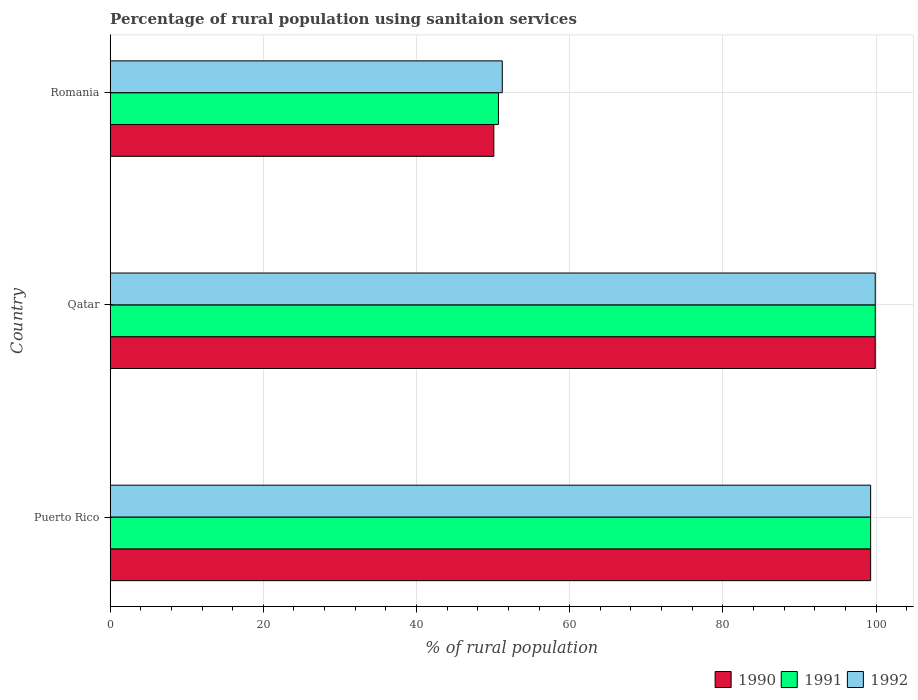How many groups of bars are there?
Your answer should be very brief. 3. Are the number of bars per tick equal to the number of legend labels?
Provide a succinct answer. Yes. What is the label of the 2nd group of bars from the top?
Ensure brevity in your answer.  Qatar. What is the percentage of rural population using sanitaion services in 1990 in Romania?
Your response must be concise. 50.1. Across all countries, what is the maximum percentage of rural population using sanitaion services in 1991?
Your response must be concise. 99.9. Across all countries, what is the minimum percentage of rural population using sanitaion services in 1990?
Your response must be concise. 50.1. In which country was the percentage of rural population using sanitaion services in 1991 maximum?
Offer a very short reply. Qatar. In which country was the percentage of rural population using sanitaion services in 1991 minimum?
Your answer should be very brief. Romania. What is the total percentage of rural population using sanitaion services in 1991 in the graph?
Your answer should be very brief. 249.9. What is the difference between the percentage of rural population using sanitaion services in 1990 in Puerto Rico and that in Romania?
Keep it short and to the point. 49.2. What is the difference between the percentage of rural population using sanitaion services in 1991 in Qatar and the percentage of rural population using sanitaion services in 1990 in Puerto Rico?
Offer a very short reply. 0.6. What is the average percentage of rural population using sanitaion services in 1992 per country?
Keep it short and to the point. 83.47. What is the difference between the percentage of rural population using sanitaion services in 1990 and percentage of rural population using sanitaion services in 1991 in Qatar?
Your answer should be compact. 0. In how many countries, is the percentage of rural population using sanitaion services in 1990 greater than 52 %?
Provide a succinct answer. 2. What is the ratio of the percentage of rural population using sanitaion services in 1992 in Qatar to that in Romania?
Keep it short and to the point. 1.95. Is the difference between the percentage of rural population using sanitaion services in 1990 in Puerto Rico and Qatar greater than the difference between the percentage of rural population using sanitaion services in 1991 in Puerto Rico and Qatar?
Make the answer very short. No. What is the difference between the highest and the second highest percentage of rural population using sanitaion services in 1992?
Give a very brief answer. 0.6. What is the difference between the highest and the lowest percentage of rural population using sanitaion services in 1992?
Provide a succinct answer. 48.7. Is the sum of the percentage of rural population using sanitaion services in 1991 in Qatar and Romania greater than the maximum percentage of rural population using sanitaion services in 1992 across all countries?
Ensure brevity in your answer.  Yes. What does the 1st bar from the top in Romania represents?
Provide a short and direct response. 1992. What does the 1st bar from the bottom in Qatar represents?
Keep it short and to the point. 1990. Is it the case that in every country, the sum of the percentage of rural population using sanitaion services in 1990 and percentage of rural population using sanitaion services in 1992 is greater than the percentage of rural population using sanitaion services in 1991?
Offer a very short reply. Yes. How many bars are there?
Your response must be concise. 9. Are all the bars in the graph horizontal?
Offer a terse response. Yes. How many countries are there in the graph?
Your answer should be compact. 3. What is the difference between two consecutive major ticks on the X-axis?
Provide a short and direct response. 20. Are the values on the major ticks of X-axis written in scientific E-notation?
Provide a succinct answer. No. Does the graph contain any zero values?
Give a very brief answer. No. Does the graph contain grids?
Offer a very short reply. Yes. Where does the legend appear in the graph?
Your answer should be very brief. Bottom right. How many legend labels are there?
Your answer should be very brief. 3. How are the legend labels stacked?
Keep it short and to the point. Horizontal. What is the title of the graph?
Keep it short and to the point. Percentage of rural population using sanitaion services. Does "2008" appear as one of the legend labels in the graph?
Make the answer very short. No. What is the label or title of the X-axis?
Offer a terse response. % of rural population. What is the % of rural population in 1990 in Puerto Rico?
Your answer should be very brief. 99.3. What is the % of rural population of 1991 in Puerto Rico?
Provide a short and direct response. 99.3. What is the % of rural population in 1992 in Puerto Rico?
Keep it short and to the point. 99.3. What is the % of rural population of 1990 in Qatar?
Your answer should be compact. 99.9. What is the % of rural population of 1991 in Qatar?
Offer a very short reply. 99.9. What is the % of rural population in 1992 in Qatar?
Your answer should be very brief. 99.9. What is the % of rural population of 1990 in Romania?
Offer a very short reply. 50.1. What is the % of rural population in 1991 in Romania?
Provide a short and direct response. 50.7. What is the % of rural population of 1992 in Romania?
Your response must be concise. 51.2. Across all countries, what is the maximum % of rural population of 1990?
Ensure brevity in your answer.  99.9. Across all countries, what is the maximum % of rural population of 1991?
Provide a succinct answer. 99.9. Across all countries, what is the maximum % of rural population of 1992?
Make the answer very short. 99.9. Across all countries, what is the minimum % of rural population of 1990?
Your response must be concise. 50.1. Across all countries, what is the minimum % of rural population of 1991?
Offer a very short reply. 50.7. Across all countries, what is the minimum % of rural population in 1992?
Offer a very short reply. 51.2. What is the total % of rural population of 1990 in the graph?
Offer a very short reply. 249.3. What is the total % of rural population in 1991 in the graph?
Your answer should be very brief. 249.9. What is the total % of rural population of 1992 in the graph?
Offer a very short reply. 250.4. What is the difference between the % of rural population of 1991 in Puerto Rico and that in Qatar?
Your answer should be very brief. -0.6. What is the difference between the % of rural population in 1990 in Puerto Rico and that in Romania?
Your answer should be compact. 49.2. What is the difference between the % of rural population in 1991 in Puerto Rico and that in Romania?
Keep it short and to the point. 48.6. What is the difference between the % of rural population in 1992 in Puerto Rico and that in Romania?
Provide a succinct answer. 48.1. What is the difference between the % of rural population of 1990 in Qatar and that in Romania?
Your answer should be compact. 49.8. What is the difference between the % of rural population of 1991 in Qatar and that in Romania?
Provide a succinct answer. 49.2. What is the difference between the % of rural population in 1992 in Qatar and that in Romania?
Offer a terse response. 48.7. What is the difference between the % of rural population in 1990 in Puerto Rico and the % of rural population in 1991 in Qatar?
Offer a very short reply. -0.6. What is the difference between the % of rural population of 1990 in Puerto Rico and the % of rural population of 1992 in Qatar?
Your response must be concise. -0.6. What is the difference between the % of rural population in 1990 in Puerto Rico and the % of rural population in 1991 in Romania?
Provide a succinct answer. 48.6. What is the difference between the % of rural population of 1990 in Puerto Rico and the % of rural population of 1992 in Romania?
Give a very brief answer. 48.1. What is the difference between the % of rural population of 1991 in Puerto Rico and the % of rural population of 1992 in Romania?
Provide a short and direct response. 48.1. What is the difference between the % of rural population of 1990 in Qatar and the % of rural population of 1991 in Romania?
Offer a very short reply. 49.2. What is the difference between the % of rural population in 1990 in Qatar and the % of rural population in 1992 in Romania?
Offer a terse response. 48.7. What is the difference between the % of rural population of 1991 in Qatar and the % of rural population of 1992 in Romania?
Provide a short and direct response. 48.7. What is the average % of rural population of 1990 per country?
Ensure brevity in your answer.  83.1. What is the average % of rural population in 1991 per country?
Offer a very short reply. 83.3. What is the average % of rural population of 1992 per country?
Offer a very short reply. 83.47. What is the difference between the % of rural population of 1990 and % of rural population of 1992 in Puerto Rico?
Ensure brevity in your answer.  0. What is the difference between the % of rural population in 1990 and % of rural population in 1991 in Qatar?
Offer a terse response. 0. What is the difference between the % of rural population in 1991 and % of rural population in 1992 in Qatar?
Make the answer very short. 0. What is the difference between the % of rural population in 1990 and % of rural population in 1991 in Romania?
Your answer should be very brief. -0.6. What is the difference between the % of rural population of 1991 and % of rural population of 1992 in Romania?
Offer a terse response. -0.5. What is the ratio of the % of rural population of 1990 in Puerto Rico to that in Qatar?
Provide a succinct answer. 0.99. What is the ratio of the % of rural population in 1992 in Puerto Rico to that in Qatar?
Provide a short and direct response. 0.99. What is the ratio of the % of rural population of 1990 in Puerto Rico to that in Romania?
Offer a terse response. 1.98. What is the ratio of the % of rural population in 1991 in Puerto Rico to that in Romania?
Keep it short and to the point. 1.96. What is the ratio of the % of rural population of 1992 in Puerto Rico to that in Romania?
Offer a very short reply. 1.94. What is the ratio of the % of rural population of 1990 in Qatar to that in Romania?
Your answer should be very brief. 1.99. What is the ratio of the % of rural population in 1991 in Qatar to that in Romania?
Offer a terse response. 1.97. What is the ratio of the % of rural population in 1992 in Qatar to that in Romania?
Offer a terse response. 1.95. What is the difference between the highest and the second highest % of rural population of 1991?
Offer a terse response. 0.6. What is the difference between the highest and the second highest % of rural population of 1992?
Your response must be concise. 0.6. What is the difference between the highest and the lowest % of rural population of 1990?
Your answer should be compact. 49.8. What is the difference between the highest and the lowest % of rural population of 1991?
Offer a terse response. 49.2. What is the difference between the highest and the lowest % of rural population in 1992?
Make the answer very short. 48.7. 